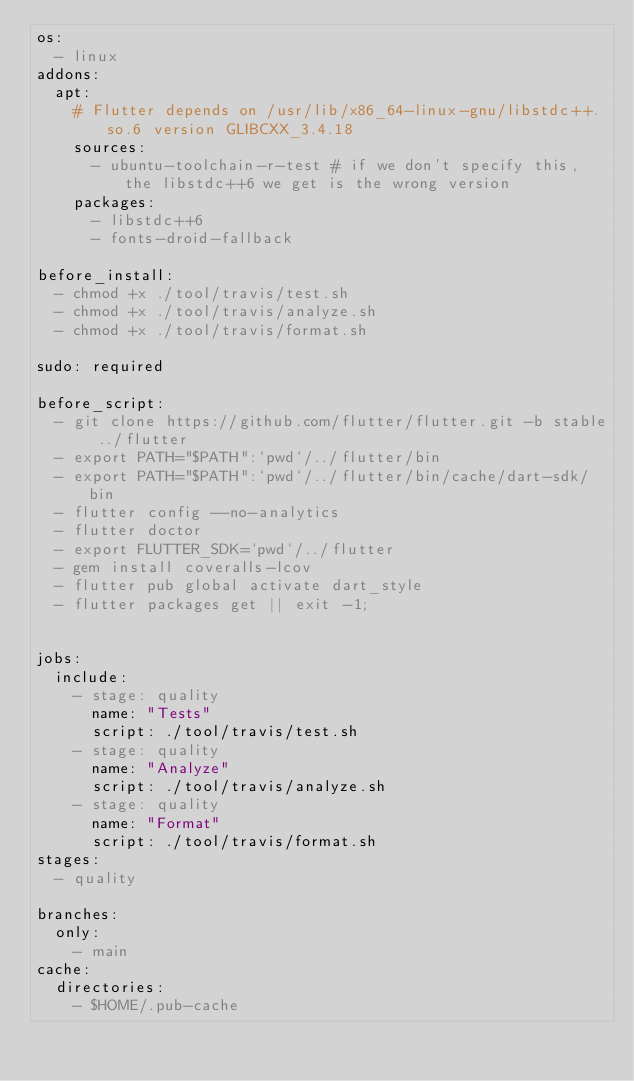<code> <loc_0><loc_0><loc_500><loc_500><_YAML_>os:
  - linux
addons:
  apt:
    # Flutter depends on /usr/lib/x86_64-linux-gnu/libstdc++.so.6 version GLIBCXX_3.4.18
    sources:
      - ubuntu-toolchain-r-test # if we don't specify this, the libstdc++6 we get is the wrong version
    packages:
      - libstdc++6
      - fonts-droid-fallback

before_install:
  - chmod +x ./tool/travis/test.sh
  - chmod +x ./tool/travis/analyze.sh
  - chmod +x ./tool/travis/format.sh

sudo: required

before_script:
  - git clone https://github.com/flutter/flutter.git -b stable ../flutter
  - export PATH="$PATH":`pwd`/../flutter/bin
  - export PATH="$PATH":`pwd`/../flutter/bin/cache/dart-sdk/bin
  - flutter config --no-analytics
  - flutter doctor
  - export FLUTTER_SDK=`pwd`/../flutter
  - gem install coveralls-lcov
  - flutter pub global activate dart_style
  - flutter packages get || exit -1;


jobs:
  include:
    - stage: quality
      name: "Tests"
      script: ./tool/travis/test.sh
    - stage: quality
      name: "Analyze"
      script: ./tool/travis/analyze.sh
    - stage: quality
      name: "Format"
      script: ./tool/travis/format.sh
stages:
  - quality

branches:
  only:
    - main
cache:
  directories:
    - $HOME/.pub-cache</code> 